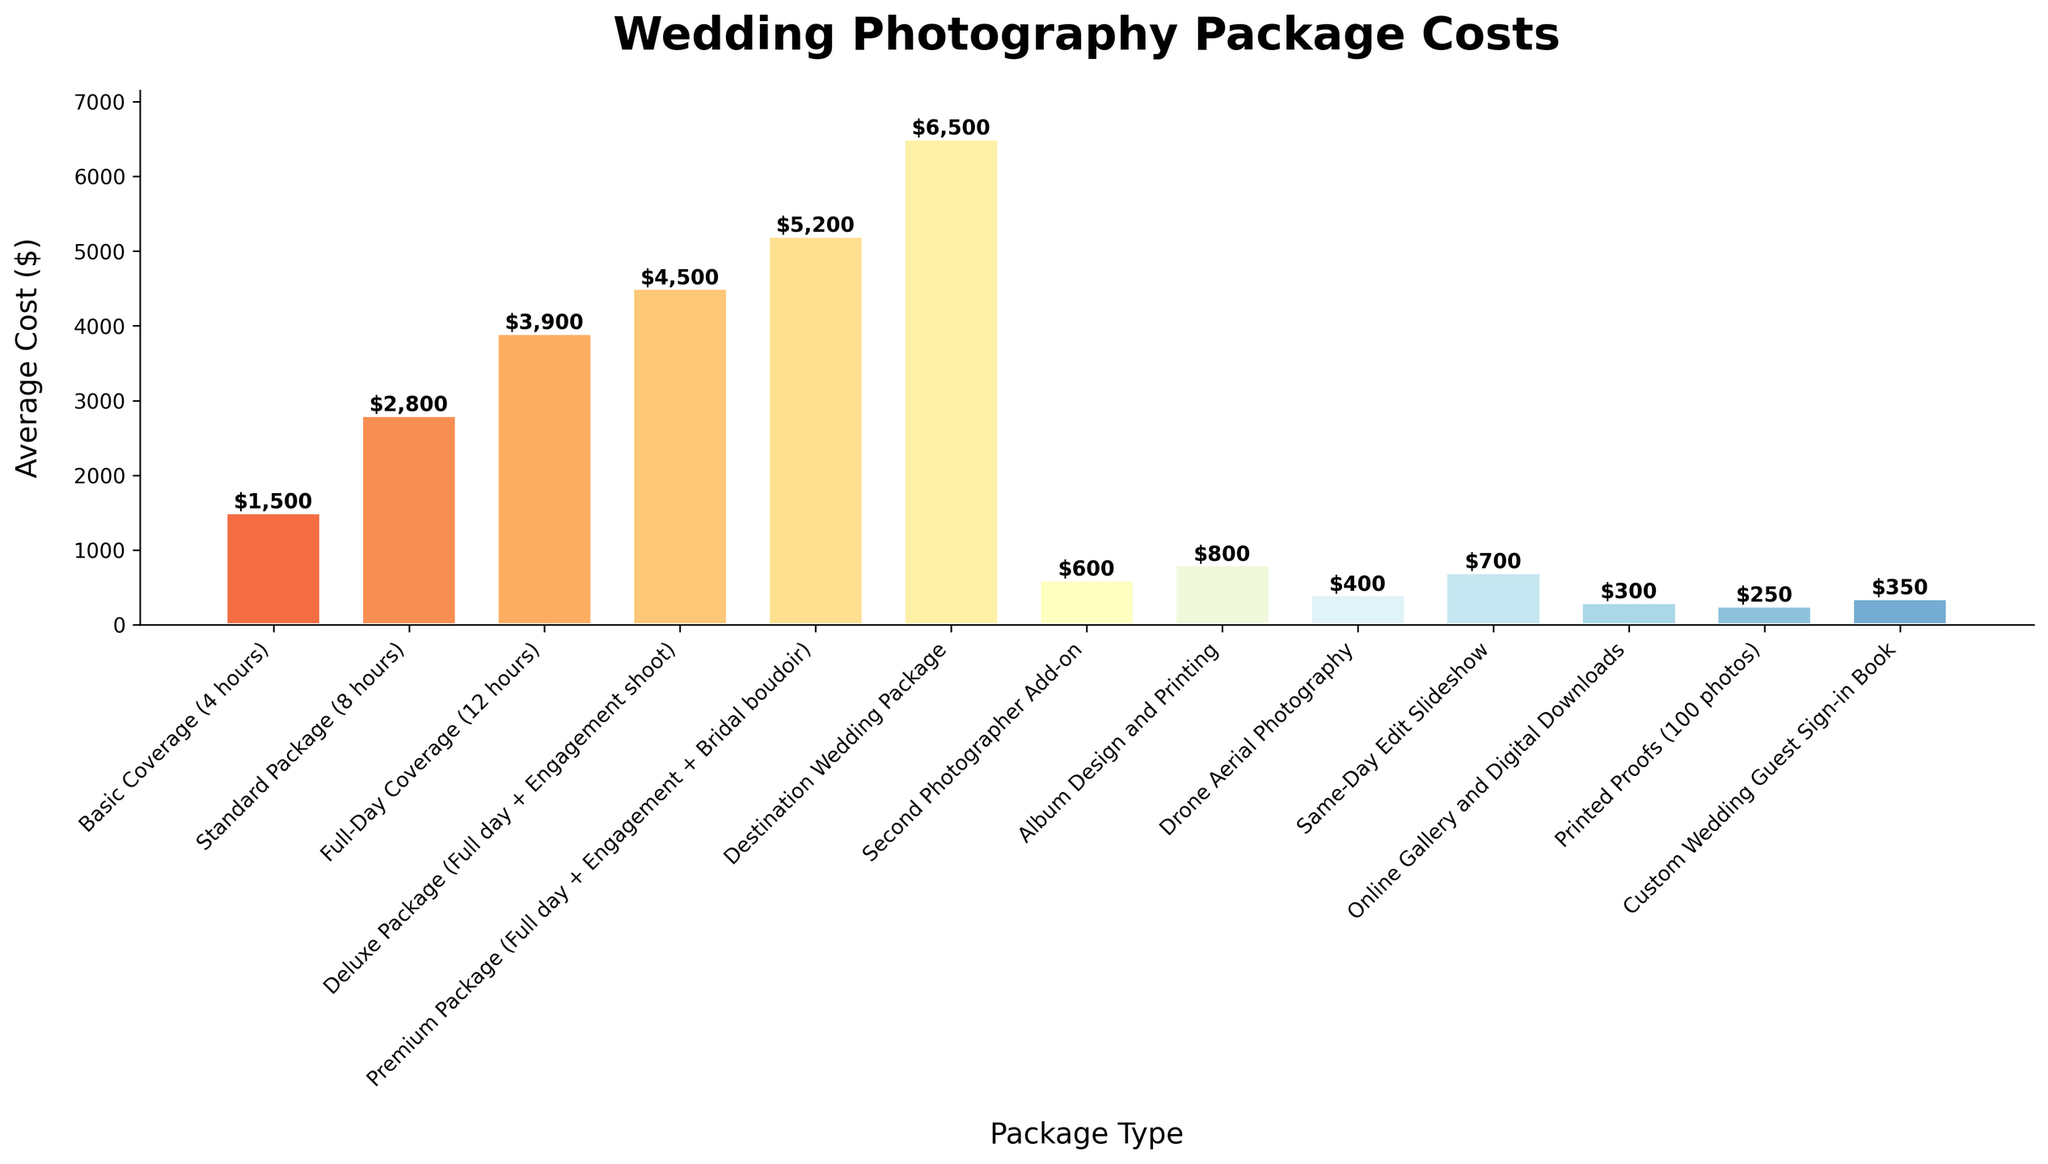What's the most expensive wedding photography package? By looking at the bar heights and corresponding labels, the Destination Wedding Package has the highest cost at $6500 as indicated on the bar.
Answer: Destination Wedding Package Which package includes an engagement shoot and how much does it cost? By looking at the labels and corresponding costs, the Deluxe Package (Full day + Engagement shoot) includes an engagement shoot and costs $4500.
Answer: Deluxe Package (Full day + Engagement shoot), $4500 How much more expensive is the Premium Package (Full day + Engagement + Bridal boudoir) compared to the Full-Day Coverage (12 hours)? Subtract the cost of the Full-Day Coverage from the cost of the Premium Package: $5200 - $3900 = $1300.
Answer: $1300 Which add-on has the highest cost, and what is it? By checking the costs of the add-ons, the Second Photographer Add-on has the highest cost at $600.
Answer: Second Photographer Add-on, $600 If I wanted both the Drone Aerial Photography and Same-Day Edit Slideshow, how much would it cost in total? Add the costs of Drone Aerial Photography and Same-Day Edit Slideshow: $400 + $700 = $1100.
Answer: $1100 Which package has the lowest average cost and what is the amount? The Basic Coverage (4 hours) has the lowest average cost as indicated by the shortest bar, with an amount of $1500.
Answer: Basic Coverage (4 hours), $1500 Between the Album Design and Printing and the Custom Wedding Guest Sign-in Book, which one is cheaper and by how much? Subtract the cost of the Custom Wedding Guest Sign-in Book from the cost of Album Design and Printing: $800 - $350 = $450.
Answer: Custom Wedding Guest Sign-in Book, $450 What's the combined cost of the Full-Day Coverage (12 hours), Second Photographer Add-on, and Online Gallery and Digital Downloads? Add the costs of Full-Day Coverage, Second Photographer Add-on, and Online Gallery and Digital Downloads: $3900 + $600 + $300 = $4800.
Answer: $4800 Which package offers more hours of coverage at a higher cost: the Standard Package (8 hours) or the Basic Coverage (4 hours)? The Standard Package (8 hours) is more expensive at $2800 compared to the Basic Coverage (4 hours) at $1500 and offers more hours.
Answer: Standard Package (8 hours) Is the average cost of the Deluxe Package higher or lower than the combined cost of Printed Proofs (100 photos) and Custom Wedding Guest Sign-in Book? The combined cost of Printed Proofs and Custom Wedding Guest Sign-in Book is $250 + $350 = $600. The Deluxe Package costs $4500, which is higher.
Answer: Higher 